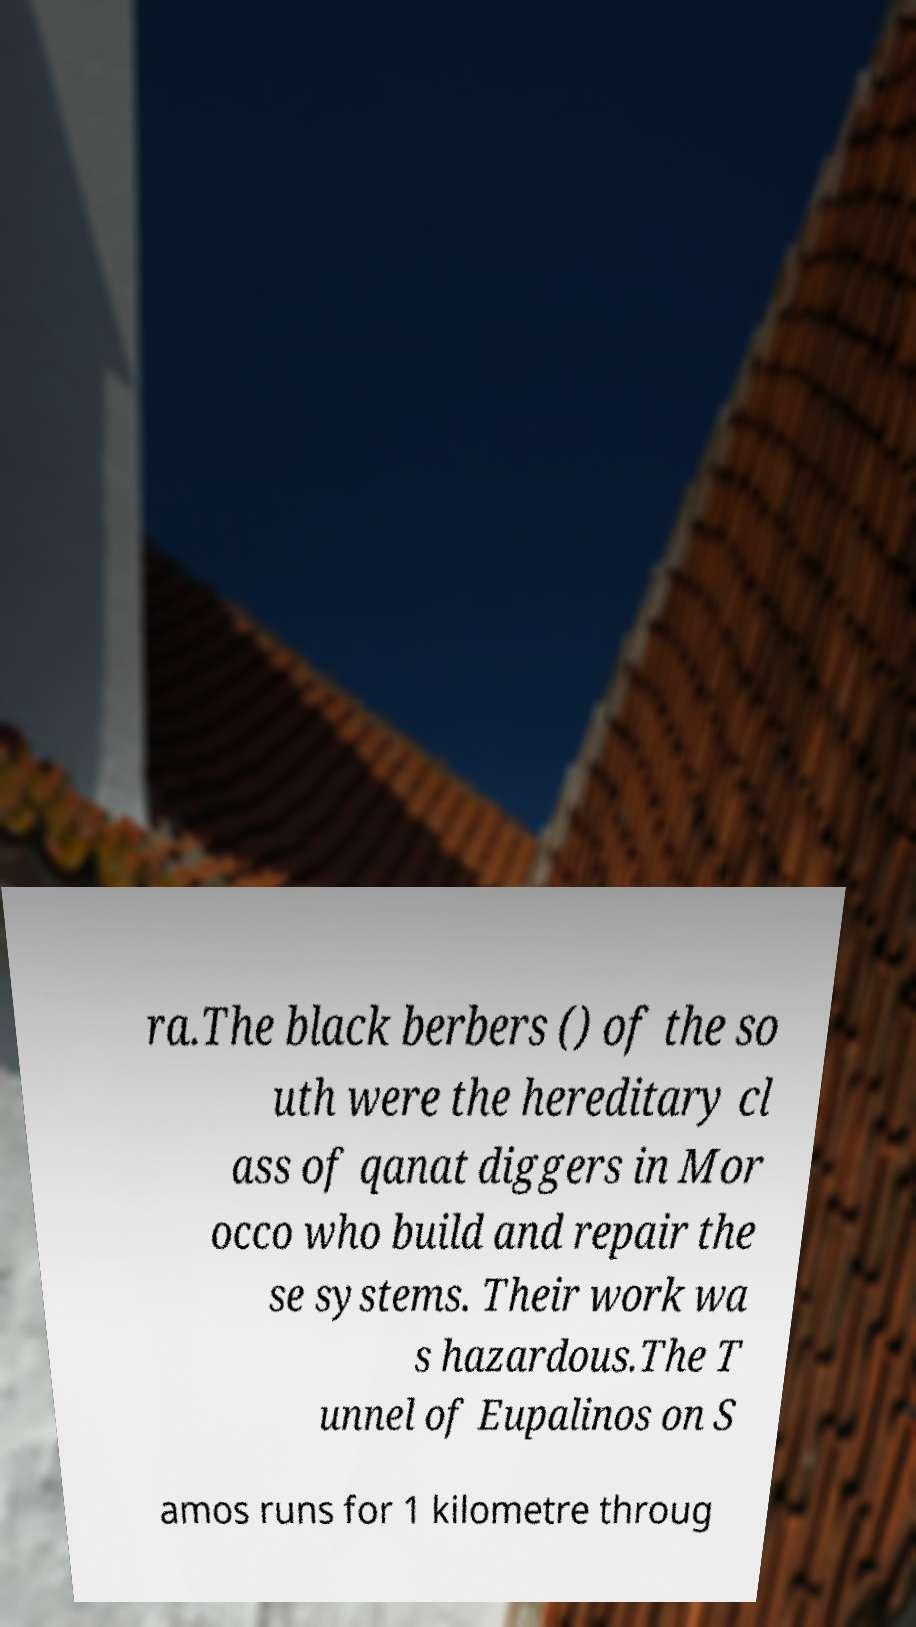Could you assist in decoding the text presented in this image and type it out clearly? ra.The black berbers () of the so uth were the hereditary cl ass of qanat diggers in Mor occo who build and repair the se systems. Their work wa s hazardous.The T unnel of Eupalinos on S amos runs for 1 kilometre throug 